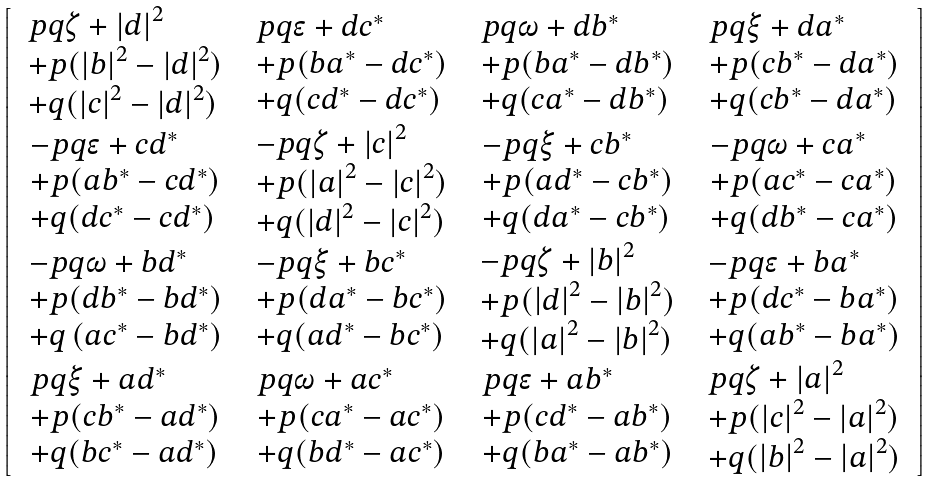Convert formula to latex. <formula><loc_0><loc_0><loc_500><loc_500>\left [ \begin{array} { c c c c } \begin{array} { l } p q \zeta + \left | d \right | ^ { 2 } \\ + p ( \left | b \right | ^ { 2 } - \left | d \right | ^ { 2 } ) \\ + q ( \left | c \right | ^ { 2 } - \left | d \right | ^ { 2 } ) \end{array} & \begin{array} { l } p q \epsilon + d c ^ { \ast } \\ + p ( b a ^ { \ast } - d c ^ { \ast } ) \\ + q ( c d ^ { \ast } - d c ^ { \ast } ) \end{array} & \begin{array} { l } p q \omega + d b ^ { \ast } \\ + p ( b a ^ { \ast } - d b ^ { \ast } ) \\ + q ( c a ^ { \ast } - d b ^ { \ast } ) \end{array} & \begin{array} { l } p q \xi + d a ^ { \ast } \\ + p ( c b ^ { \ast } - d a ^ { \ast } ) \\ + q ( c b ^ { \ast } - d a ^ { \ast } ) \end{array} \\ \begin{array} { l } - p q \epsilon + c d ^ { \ast } \\ + p ( a b ^ { \ast } - c d ^ { \ast } ) \\ + q ( d c ^ { \ast } - c d ^ { \ast } ) \end{array} & \begin{array} { l } - p q \zeta + \left | c \right | ^ { 2 } \\ + p ( \left | a \right | ^ { 2 } - \left | c \right | ^ { 2 } ) \\ + q ( \left | d \right | ^ { 2 } - \left | c \right | ^ { 2 } ) \end{array} & \begin{array} { l } - p q \xi + c b ^ { \ast } \\ + p ( a d ^ { \ast } - c b ^ { \ast } ) \\ + q ( d a ^ { \ast } - c b ^ { \ast } ) \end{array} & \begin{array} { l } - p q \omega + c a ^ { \ast } \\ + p ( a c ^ { \ast } - c a ^ { \ast } ) \\ + q ( d b ^ { \ast } - c a ^ { \ast } ) \end{array} \\ \begin{array} { l } - p q \omega + b d ^ { \ast } \\ + p ( d b ^ { \ast } - b d ^ { \ast } ) \\ + q \left ( a c ^ { \ast } - b d ^ { \ast } \right ) \end{array} & \begin{array} { l } - p q \xi + b c ^ { \ast } \\ + p ( d a ^ { \ast } - b c ^ { \ast } ) \\ + q ( a d ^ { \ast } - b c ^ { \ast } ) \end{array} & \begin{array} { l } - p q \zeta + \left | b \right | ^ { 2 } \\ + p ( \left | d \right | ^ { 2 } - \left | b \right | ^ { 2 } ) \\ + q ( \left | a \right | ^ { 2 } - \left | b \right | ^ { 2 } ) \end{array} & \begin{array} { l } - p q \epsilon + b a ^ { \ast } \\ + p ( d c ^ { \ast } - b a ^ { \ast } ) \\ + q ( a b ^ { \ast } - b a ^ { \ast } ) \end{array} \\ \begin{array} { l } p q \xi + a d ^ { \ast } \\ + p ( c b ^ { \ast } - a d ^ { \ast } ) \\ + q ( b c ^ { \ast } - a d ^ { \ast } ) \end{array} & \begin{array} { l } p q \omega + a c ^ { \ast } \\ + p ( c a ^ { \ast } - a c ^ { \ast } ) \\ + q ( b d ^ { \ast } - a c ^ { \ast } ) \end{array} & \begin{array} { l } p q \epsilon + a b ^ { \ast } \\ + p ( c d ^ { \ast } - a b ^ { \ast } ) \\ + q ( b a ^ { \ast } - a b ^ { \ast } ) \end{array} & \begin{array} { l } p q \zeta + \left | a \right | ^ { 2 } \\ + p ( \left | c \right | ^ { 2 } - \left | a \right | ^ { 2 } ) \\ + q ( \left | b \right | ^ { 2 } - \left | a \right | ^ { 2 } ) \end{array} \end{array} \right ]</formula> 